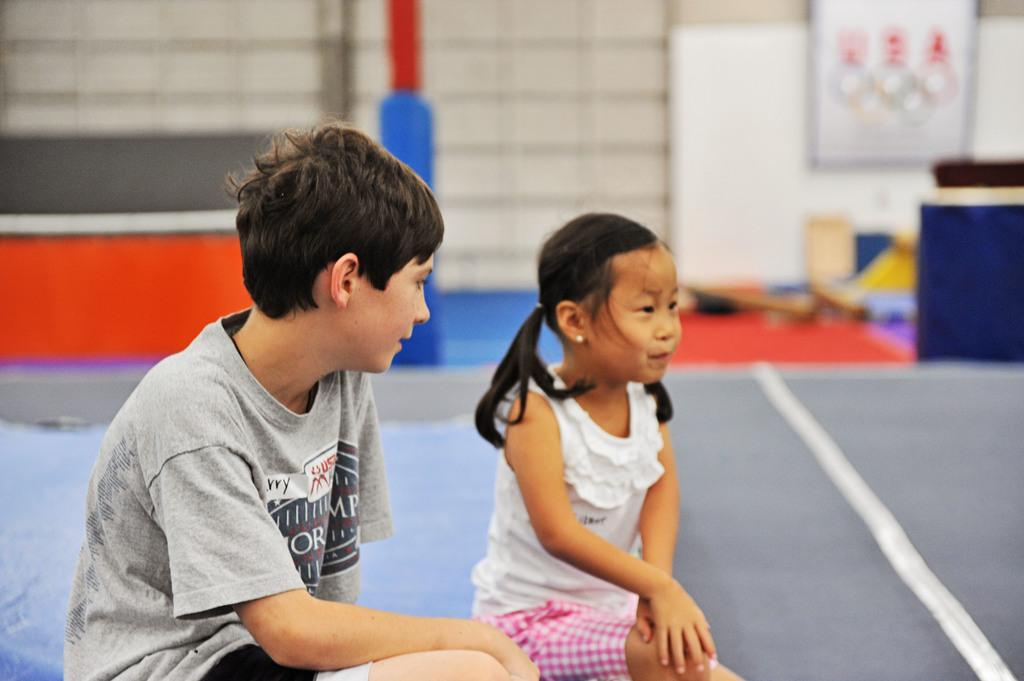How many people are sitting in the image? There are two people sitting in the image. What can be seen behind the people? There is a background in the image, which includes a board with images. Can you describe the objects on the right side of the image? Unfortunately, the provided facts do not specify the objects on the right side of the image. What might be the purpose of the board with images in the background? The board with images in the background could be used for displaying information, decoration, or as part of a presentation. Are the people in the image sleeping? There is no indication in the image that the people are sleeping; they are sitting. Can you tell me how many nails are visible in the image? There is no mention of nails in the provided facts, so it is impossible to determine how many are visible in the image. 